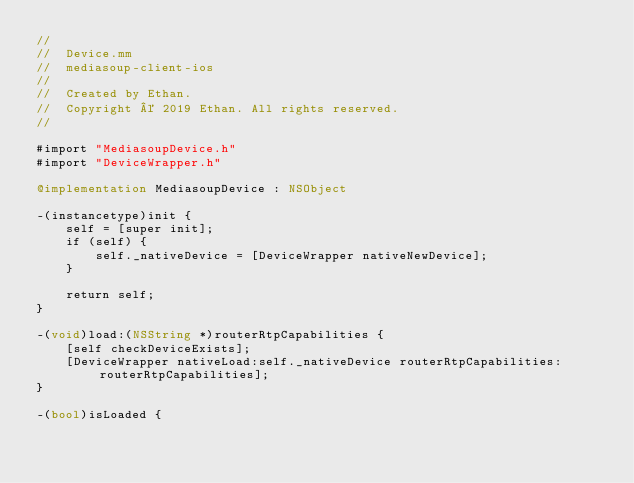Convert code to text. <code><loc_0><loc_0><loc_500><loc_500><_ObjectiveC_>//
//  Device.mm
//  mediasoup-client-ios
//
//  Created by Ethan.
//  Copyright © 2019 Ethan. All rights reserved.
//

#import "MediasoupDevice.h"
#import "DeviceWrapper.h"

@implementation MediasoupDevice : NSObject

-(instancetype)init {
    self = [super init];
    if (self) {
        self._nativeDevice = [DeviceWrapper nativeNewDevice];
    }
    
    return self;
}

-(void)load:(NSString *)routerRtpCapabilities {
    [self checkDeviceExists];
    [DeviceWrapper nativeLoad:self._nativeDevice routerRtpCapabilities:routerRtpCapabilities];
}

-(bool)isLoaded {</code> 